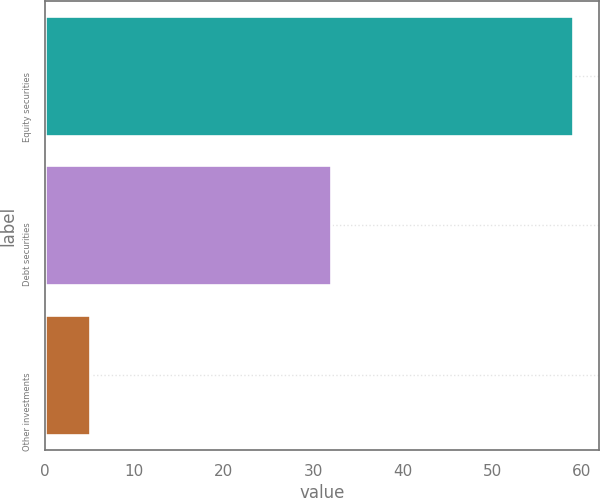Convert chart. <chart><loc_0><loc_0><loc_500><loc_500><bar_chart><fcel>Equity securities<fcel>Debt securities<fcel>Other investments<nl><fcel>59<fcel>32<fcel>5<nl></chart> 